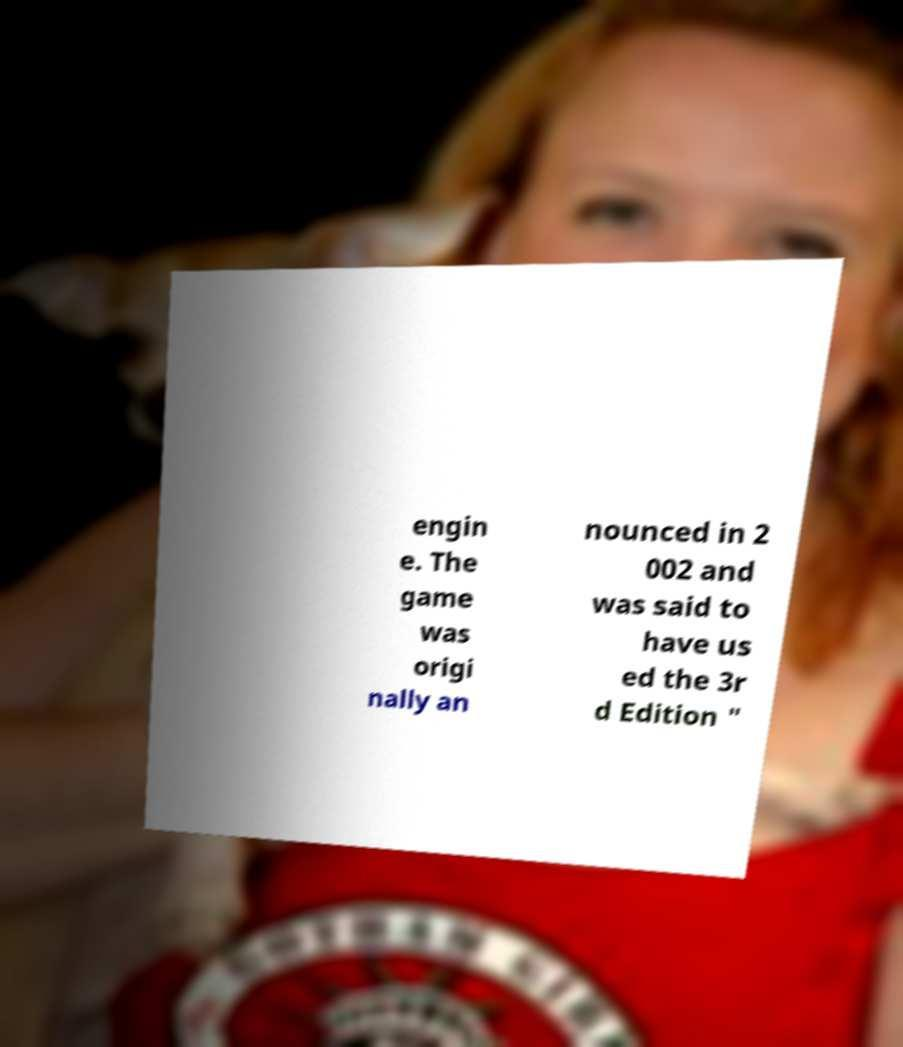Please identify and transcribe the text found in this image. engin e. The game was origi nally an nounced in 2 002 and was said to have us ed the 3r d Edition " 